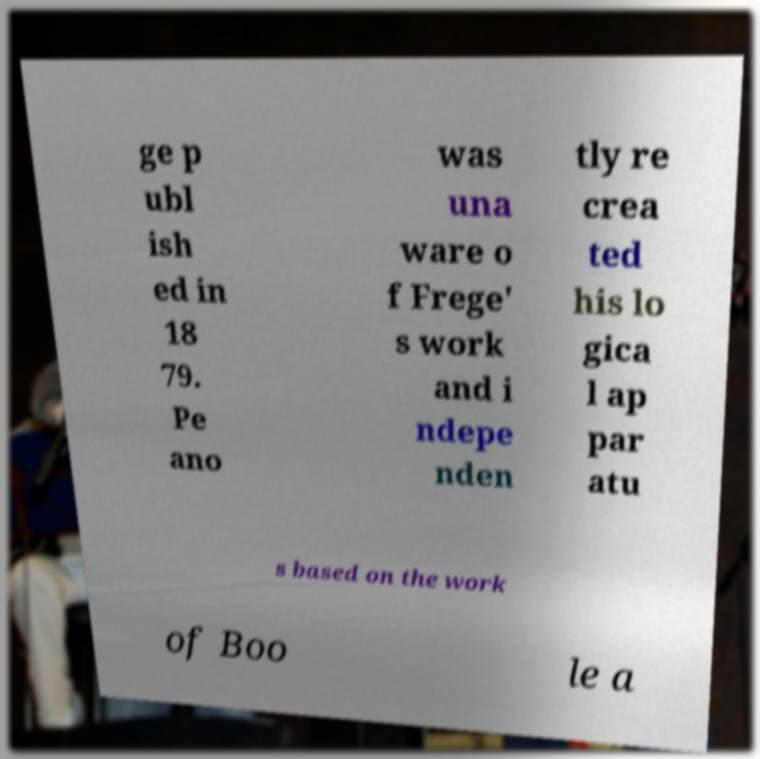Please read and relay the text visible in this image. What does it say? ge p ubl ish ed in 18 79. Pe ano was una ware o f Frege' s work and i ndepe nden tly re crea ted his lo gica l ap par atu s based on the work of Boo le a 